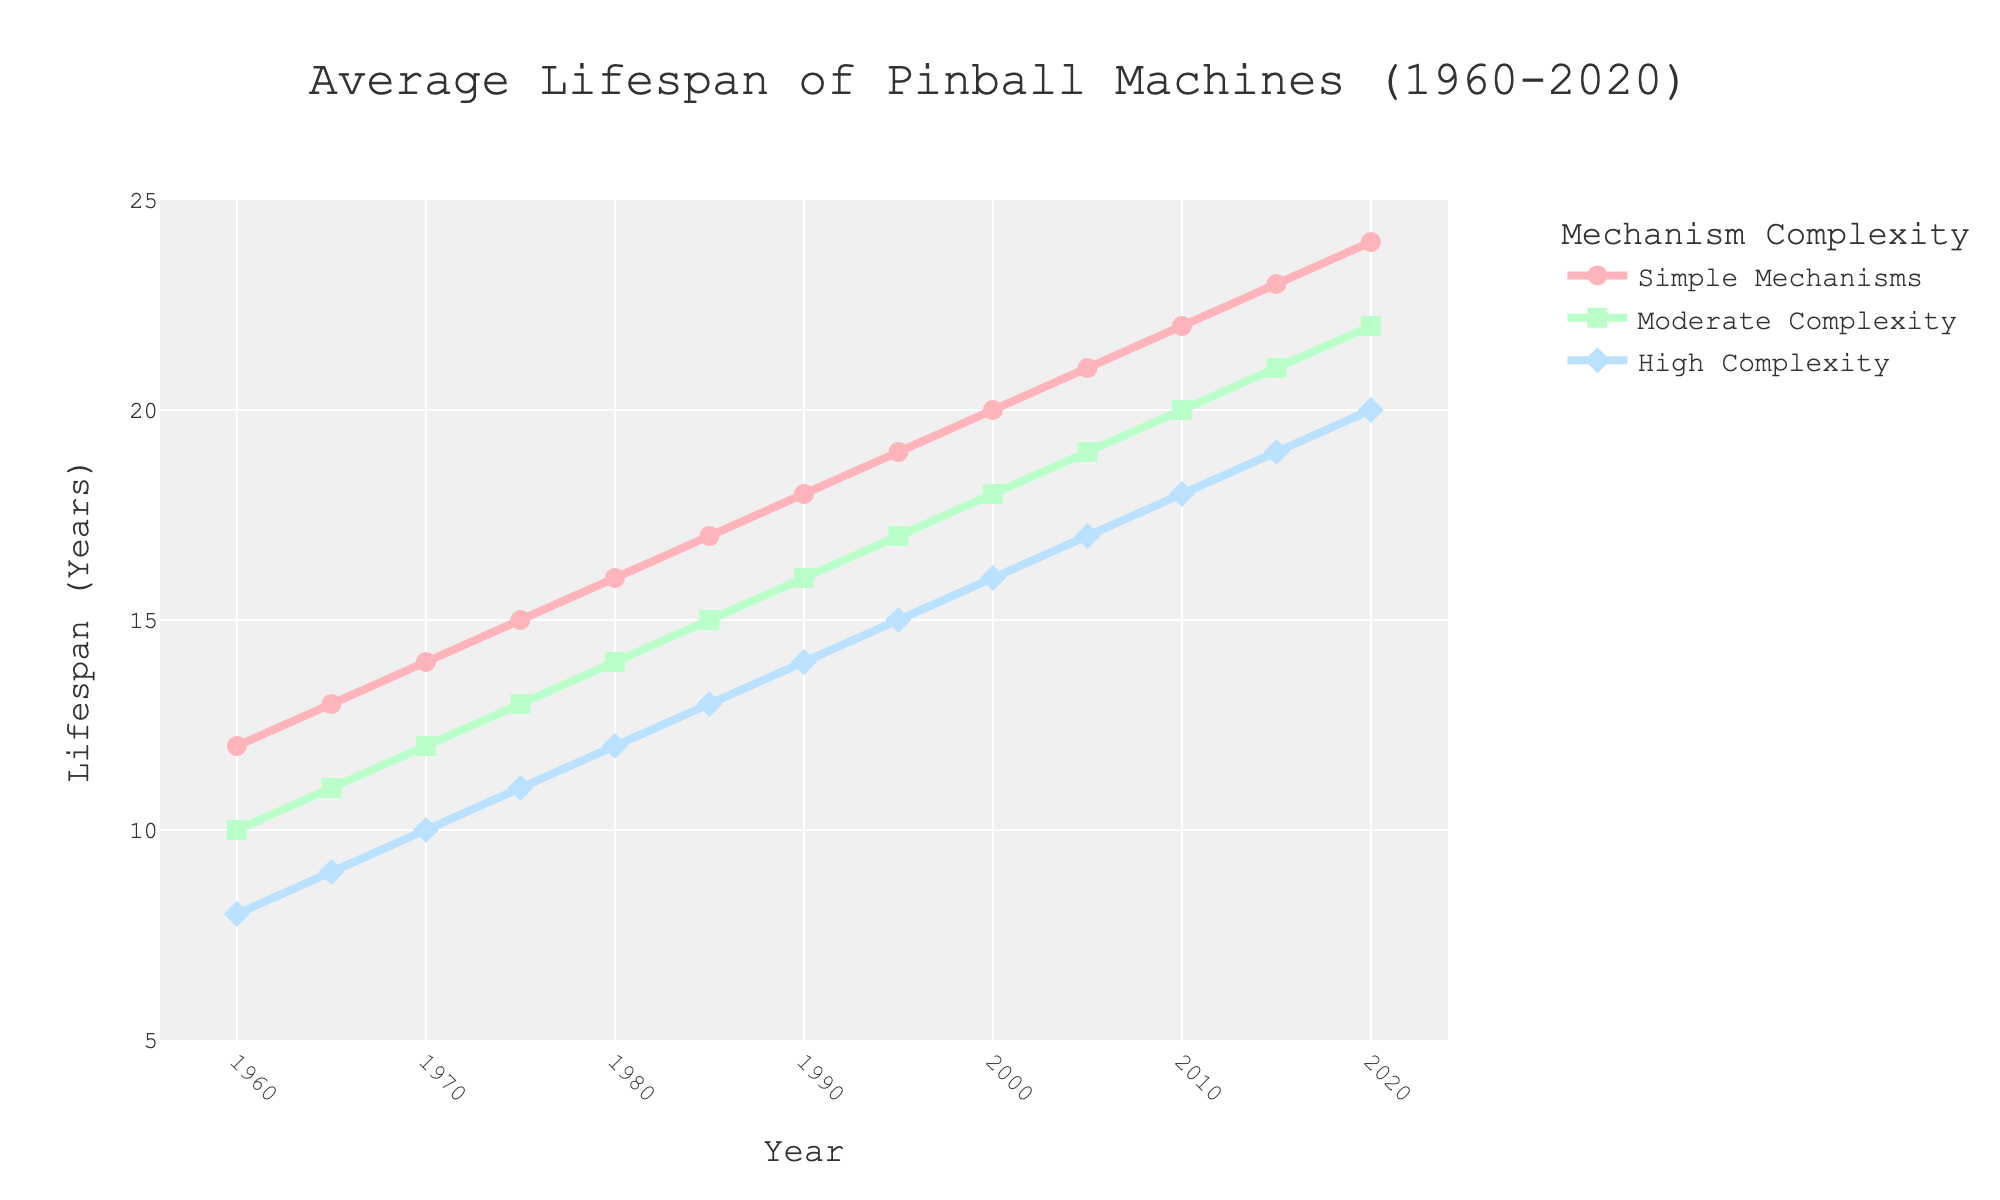What's the difference in lifespan between machines with simple mechanisms and high complexity in 1980? In 1980, the lifespan of machines with simple mechanisms is 16 years, and for high complexity, it is 12 years. The difference is 16 - 12 = 4 years.
Answer: 4 years Which category of pinball machine has the longest lifespan in 2010? In 2010, the lifespan values are 22 years for simple mechanisms, 20 years for moderate complexity, and 18 years for high complexity. Therefore, machines with simple mechanisms have the longest lifespan.
Answer: Simple mechanisms What is the overall trend in the lifespan of pinball machines with moderate complexity from 1960 to 2020? From 1960 to 2020, the lifespan for moderate complexity machines increases from 10 years to 22 years. This indicates a consistent increasing trend.
Answer: Consistently increasing By how many years did the lifespan of machines with simple mechanisms increase from 1960 to 2020? In 1960, the lifespan of machines with simple mechanisms is 12 years, and in 2020 it is 24 years. The increase is 24 - 12 = 12 years.
Answer: 12 years In which year do machines with high complexity mechanisms reach an average lifespan of 15 years? Based on the plot, high complexity mechanisms reach a lifespan of 15 years in the year 1995.
Answer: 1995 Compare the lifespans of machines with moderate complexity in 1970 and 2020. In 1970, moderate complexity machines have an average lifespan of 12 years, whereas in 2020, they have an average lifespan of 22 years.
Answer: 1970: 12 years, 2020: 22 years What are the visual markers used for high complexity machines on the plot? High complexity machines are marked with blue diamond symbols on the plot.
Answer: Blue diamond symbols If you added the lifespans of all machine categories in 2015, what would be the total? The lifespans in 2015 are 23 years (simple), 21 years (moderate), and 19 years (high complexity). The total is 23 + 21 + 19 = 63 years.
Answer: 63 years What year did the average lifespan of pinball machines with simple mechanisms first exceed 20 years? In the year 2000, the lifespan of machines with simple mechanisms reaches 20 years. It first exceeds 20 years in 2005 when it is 21 years.
Answer: 2005 